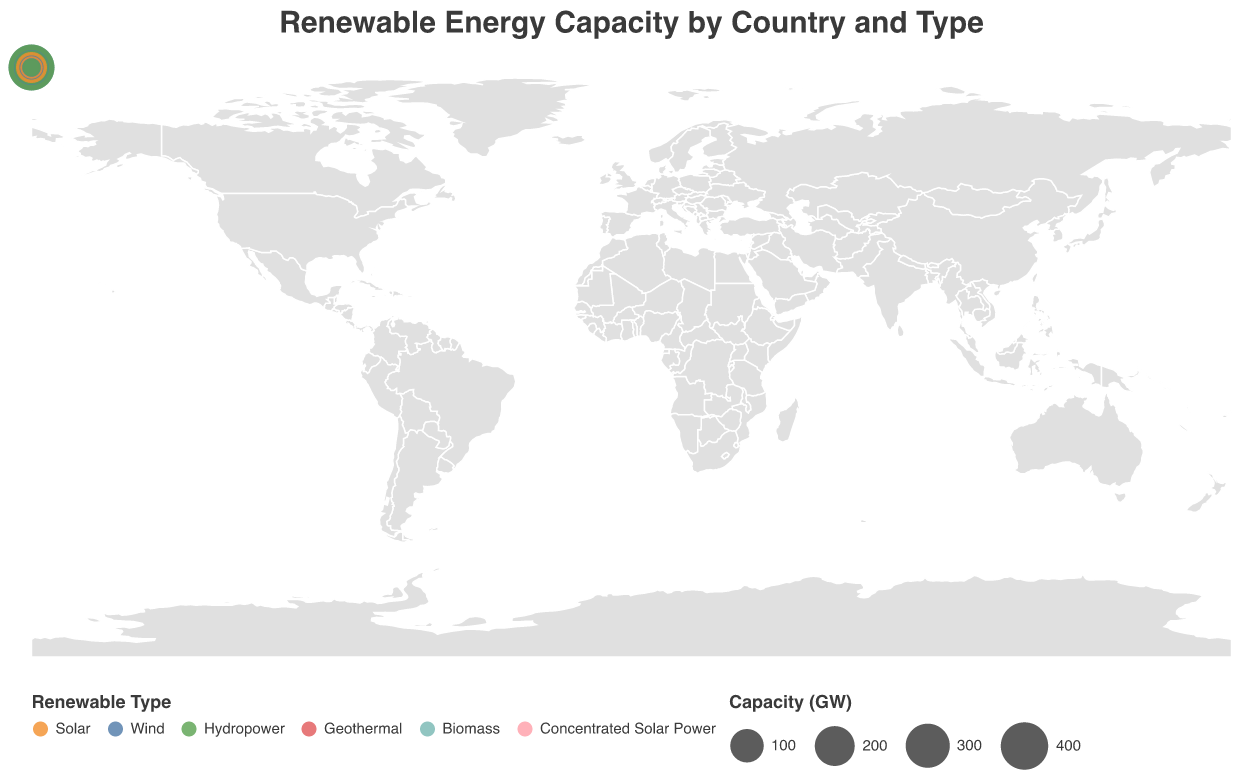Which country has the highest solar energy capacity? By examining the visual representation of solar energy capacity, China has the largest circles indicating the highest capacity compared to other countries.
Answer: China Which renewable energy type does Brazil have the highest capacity in, and what is its value? Brazil's hydropower capacity has the largest-sized circle in the visual representation, indicating the highest capacity.
Answer: Hydropower, 109 GW What is the combined renewable energy capacity for the United States? Summing up the capacities for solar (95 GW), wind (122 GW), and geothermal (3.6 GW) gives a total capacity. 95 + 122 + 3.6 = 220.6 GW
Answer: 220.6 GW Compare the wind energy capacities of China and Germany. Which country has more, and by how much? China has a wind capacity of 348 GW, and Germany has 64 GW. The difference is 348 - 64 = 284 GW, so China has significantly more wind energy capacity.
Answer: China, 284 GW Which country in the plot has the smallest capacity for geothermal energy, and what is the value? Japan has the smallest circle for geothermal energy in the visual representation, with a capacity of 0.5 GW.
Answer: Japan, 0.5 GW What's the average solar energy capacity among the listed countries? To find the average, sum the solar capacities of China (308 GW), United States (95 GW), Germany (59 GW), India (49 GW), Japan (74 GW), Spain (15 GW), and Australia (20 GW) and divide by the number of countries. (308 + 95 + 59 + 49 + 74 + 15 + 20) / 7 = 620 / 7 ≈ 88.57 GW
Answer: 88.57 GW Which country has the most diverse types of renewable energy sources represented? By observing the different renewable types for each country, the United States has solar, wind, and geothermal, showing a broad range.
Answer: United States How does Australia's capacity for wind energy compare to solar energy? Australia's wind capacity is 9.8 GW, while its solar capacity is 20 GW, thus solar capacity is higher.
Answer: Solar capacity is higher Identify two countries that primarily rely on hydropower for their renewable energy and provide their respective capacities. China and Brazil are primarily focused on hydropower, with capacities of 356 GW and 109 GW respectively.
Answer: China (356 GW) and Brazil (109 GW) What is the total capacity of biomass energy sources across all countries? Summing the biomass capacities of Germany (8.4 GW) and Brazil (15.8 GW) gives a total capacity of 8.4 + 15.8 = 24.2 GW.
Answer: 24.2 GW 